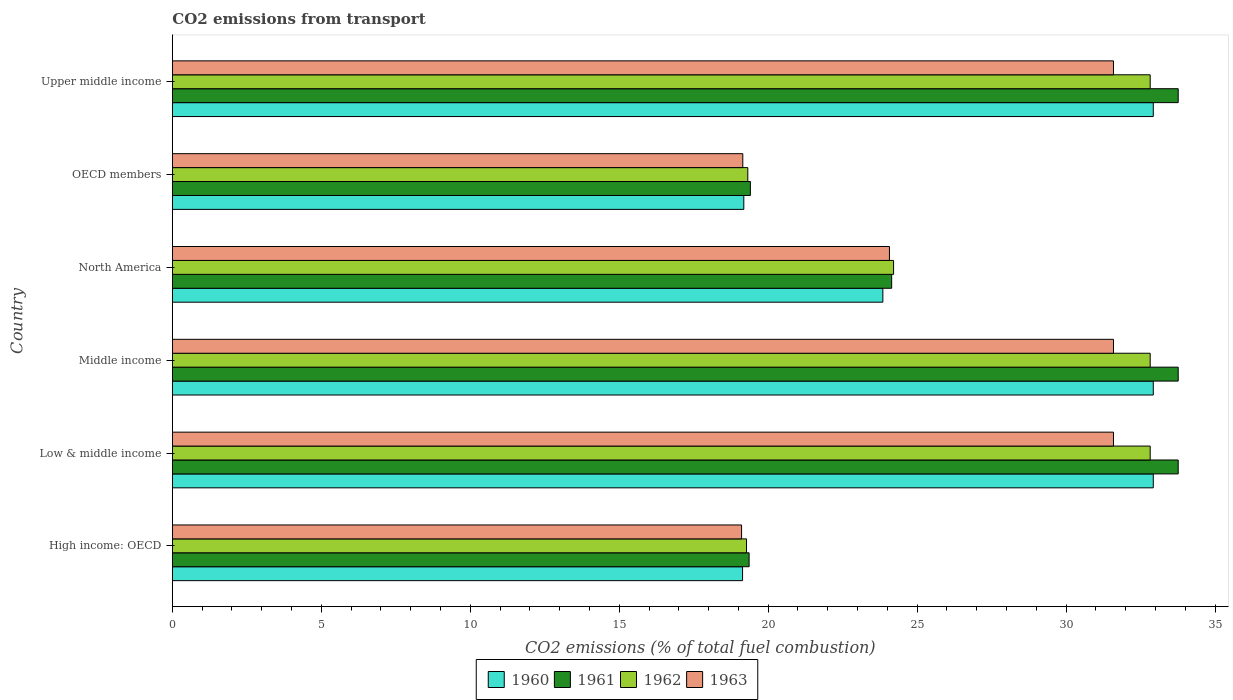How many different coloured bars are there?
Offer a terse response. 4. How many groups of bars are there?
Provide a succinct answer. 6. Are the number of bars per tick equal to the number of legend labels?
Provide a short and direct response. Yes. In how many cases, is the number of bars for a given country not equal to the number of legend labels?
Provide a succinct answer. 0. What is the total CO2 emitted in 1960 in Upper middle income?
Ensure brevity in your answer.  32.93. Across all countries, what is the maximum total CO2 emitted in 1961?
Keep it short and to the point. 33.76. Across all countries, what is the minimum total CO2 emitted in 1962?
Your answer should be compact. 19.27. In which country was the total CO2 emitted in 1963 minimum?
Offer a terse response. High income: OECD. What is the total total CO2 emitted in 1962 in the graph?
Ensure brevity in your answer.  161.27. What is the difference between the total CO2 emitted in 1963 in Middle income and that in Upper middle income?
Your answer should be very brief. 0. What is the difference between the total CO2 emitted in 1963 in North America and the total CO2 emitted in 1960 in Low & middle income?
Offer a very short reply. -8.86. What is the average total CO2 emitted in 1962 per country?
Your response must be concise. 26.88. What is the difference between the total CO2 emitted in 1961 and total CO2 emitted in 1963 in Upper middle income?
Make the answer very short. 2.17. What is the ratio of the total CO2 emitted in 1962 in North America to that in OECD members?
Provide a succinct answer. 1.25. What is the difference between the highest and the second highest total CO2 emitted in 1961?
Provide a short and direct response. 0. What is the difference between the highest and the lowest total CO2 emitted in 1960?
Offer a very short reply. 13.79. Is the sum of the total CO2 emitted in 1963 in High income: OECD and Low & middle income greater than the maximum total CO2 emitted in 1961 across all countries?
Your response must be concise. Yes. Is it the case that in every country, the sum of the total CO2 emitted in 1960 and total CO2 emitted in 1962 is greater than the sum of total CO2 emitted in 1963 and total CO2 emitted in 1961?
Your response must be concise. No. How many bars are there?
Offer a terse response. 24. Are all the bars in the graph horizontal?
Provide a short and direct response. Yes. How many countries are there in the graph?
Give a very brief answer. 6. Does the graph contain any zero values?
Give a very brief answer. No. How many legend labels are there?
Provide a succinct answer. 4. What is the title of the graph?
Give a very brief answer. CO2 emissions from transport. What is the label or title of the X-axis?
Keep it short and to the point. CO2 emissions (% of total fuel combustion). What is the label or title of the Y-axis?
Keep it short and to the point. Country. What is the CO2 emissions (% of total fuel combustion) of 1960 in High income: OECD?
Offer a very short reply. 19.14. What is the CO2 emissions (% of total fuel combustion) of 1961 in High income: OECD?
Ensure brevity in your answer.  19.36. What is the CO2 emissions (% of total fuel combustion) in 1962 in High income: OECD?
Keep it short and to the point. 19.27. What is the CO2 emissions (% of total fuel combustion) in 1963 in High income: OECD?
Offer a terse response. 19.11. What is the CO2 emissions (% of total fuel combustion) of 1960 in Low & middle income?
Your answer should be compact. 32.93. What is the CO2 emissions (% of total fuel combustion) of 1961 in Low & middle income?
Offer a very short reply. 33.76. What is the CO2 emissions (% of total fuel combustion) of 1962 in Low & middle income?
Your response must be concise. 32.82. What is the CO2 emissions (% of total fuel combustion) of 1963 in Low & middle income?
Provide a succinct answer. 31.59. What is the CO2 emissions (% of total fuel combustion) of 1960 in Middle income?
Offer a very short reply. 32.93. What is the CO2 emissions (% of total fuel combustion) of 1961 in Middle income?
Ensure brevity in your answer.  33.76. What is the CO2 emissions (% of total fuel combustion) of 1962 in Middle income?
Keep it short and to the point. 32.82. What is the CO2 emissions (% of total fuel combustion) of 1963 in Middle income?
Give a very brief answer. 31.59. What is the CO2 emissions (% of total fuel combustion) in 1960 in North America?
Provide a succinct answer. 23.85. What is the CO2 emissions (% of total fuel combustion) of 1961 in North America?
Your answer should be compact. 24.15. What is the CO2 emissions (% of total fuel combustion) of 1962 in North America?
Offer a terse response. 24.21. What is the CO2 emissions (% of total fuel combustion) of 1963 in North America?
Ensure brevity in your answer.  24.07. What is the CO2 emissions (% of total fuel combustion) of 1960 in OECD members?
Offer a very short reply. 19.18. What is the CO2 emissions (% of total fuel combustion) of 1961 in OECD members?
Make the answer very short. 19.4. What is the CO2 emissions (% of total fuel combustion) of 1962 in OECD members?
Ensure brevity in your answer.  19.32. What is the CO2 emissions (% of total fuel combustion) of 1963 in OECD members?
Offer a very short reply. 19.15. What is the CO2 emissions (% of total fuel combustion) of 1960 in Upper middle income?
Offer a terse response. 32.93. What is the CO2 emissions (% of total fuel combustion) of 1961 in Upper middle income?
Give a very brief answer. 33.76. What is the CO2 emissions (% of total fuel combustion) in 1962 in Upper middle income?
Ensure brevity in your answer.  32.82. What is the CO2 emissions (% of total fuel combustion) of 1963 in Upper middle income?
Keep it short and to the point. 31.59. Across all countries, what is the maximum CO2 emissions (% of total fuel combustion) of 1960?
Give a very brief answer. 32.93. Across all countries, what is the maximum CO2 emissions (% of total fuel combustion) in 1961?
Provide a succinct answer. 33.76. Across all countries, what is the maximum CO2 emissions (% of total fuel combustion) of 1962?
Provide a succinct answer. 32.82. Across all countries, what is the maximum CO2 emissions (% of total fuel combustion) in 1963?
Offer a very short reply. 31.59. Across all countries, what is the minimum CO2 emissions (% of total fuel combustion) of 1960?
Provide a short and direct response. 19.14. Across all countries, what is the minimum CO2 emissions (% of total fuel combustion) of 1961?
Your answer should be compact. 19.36. Across all countries, what is the minimum CO2 emissions (% of total fuel combustion) of 1962?
Your answer should be very brief. 19.27. Across all countries, what is the minimum CO2 emissions (% of total fuel combustion) in 1963?
Your answer should be very brief. 19.11. What is the total CO2 emissions (% of total fuel combustion) of 1960 in the graph?
Keep it short and to the point. 160.96. What is the total CO2 emissions (% of total fuel combustion) in 1961 in the graph?
Give a very brief answer. 164.2. What is the total CO2 emissions (% of total fuel combustion) of 1962 in the graph?
Provide a succinct answer. 161.27. What is the total CO2 emissions (% of total fuel combustion) of 1963 in the graph?
Make the answer very short. 157.1. What is the difference between the CO2 emissions (% of total fuel combustion) of 1960 in High income: OECD and that in Low & middle income?
Give a very brief answer. -13.79. What is the difference between the CO2 emissions (% of total fuel combustion) of 1961 in High income: OECD and that in Low & middle income?
Ensure brevity in your answer.  -14.4. What is the difference between the CO2 emissions (% of total fuel combustion) of 1962 in High income: OECD and that in Low & middle income?
Your answer should be very brief. -13.55. What is the difference between the CO2 emissions (% of total fuel combustion) of 1963 in High income: OECD and that in Low & middle income?
Keep it short and to the point. -12.48. What is the difference between the CO2 emissions (% of total fuel combustion) in 1960 in High income: OECD and that in Middle income?
Offer a very short reply. -13.79. What is the difference between the CO2 emissions (% of total fuel combustion) of 1961 in High income: OECD and that in Middle income?
Your answer should be very brief. -14.4. What is the difference between the CO2 emissions (% of total fuel combustion) in 1962 in High income: OECD and that in Middle income?
Your response must be concise. -13.55. What is the difference between the CO2 emissions (% of total fuel combustion) in 1963 in High income: OECD and that in Middle income?
Your answer should be compact. -12.48. What is the difference between the CO2 emissions (% of total fuel combustion) in 1960 in High income: OECD and that in North America?
Your answer should be compact. -4.71. What is the difference between the CO2 emissions (% of total fuel combustion) in 1961 in High income: OECD and that in North America?
Give a very brief answer. -4.79. What is the difference between the CO2 emissions (% of total fuel combustion) in 1962 in High income: OECD and that in North America?
Your answer should be compact. -4.94. What is the difference between the CO2 emissions (% of total fuel combustion) of 1963 in High income: OECD and that in North America?
Keep it short and to the point. -4.96. What is the difference between the CO2 emissions (% of total fuel combustion) in 1960 in High income: OECD and that in OECD members?
Provide a short and direct response. -0.04. What is the difference between the CO2 emissions (% of total fuel combustion) in 1961 in High income: OECD and that in OECD members?
Your response must be concise. -0.04. What is the difference between the CO2 emissions (% of total fuel combustion) in 1962 in High income: OECD and that in OECD members?
Your response must be concise. -0.04. What is the difference between the CO2 emissions (% of total fuel combustion) of 1963 in High income: OECD and that in OECD members?
Give a very brief answer. -0.04. What is the difference between the CO2 emissions (% of total fuel combustion) of 1960 in High income: OECD and that in Upper middle income?
Keep it short and to the point. -13.79. What is the difference between the CO2 emissions (% of total fuel combustion) in 1961 in High income: OECD and that in Upper middle income?
Provide a short and direct response. -14.4. What is the difference between the CO2 emissions (% of total fuel combustion) of 1962 in High income: OECD and that in Upper middle income?
Provide a succinct answer. -13.55. What is the difference between the CO2 emissions (% of total fuel combustion) of 1963 in High income: OECD and that in Upper middle income?
Provide a short and direct response. -12.48. What is the difference between the CO2 emissions (% of total fuel combustion) of 1962 in Low & middle income and that in Middle income?
Make the answer very short. 0. What is the difference between the CO2 emissions (% of total fuel combustion) in 1963 in Low & middle income and that in Middle income?
Keep it short and to the point. 0. What is the difference between the CO2 emissions (% of total fuel combustion) in 1960 in Low & middle income and that in North America?
Your answer should be very brief. 9.08. What is the difference between the CO2 emissions (% of total fuel combustion) of 1961 in Low & middle income and that in North America?
Your answer should be very brief. 9.62. What is the difference between the CO2 emissions (% of total fuel combustion) in 1962 in Low & middle income and that in North America?
Your response must be concise. 8.61. What is the difference between the CO2 emissions (% of total fuel combustion) in 1963 in Low & middle income and that in North America?
Provide a short and direct response. 7.52. What is the difference between the CO2 emissions (% of total fuel combustion) of 1960 in Low & middle income and that in OECD members?
Offer a very short reply. 13.75. What is the difference between the CO2 emissions (% of total fuel combustion) in 1961 in Low & middle income and that in OECD members?
Provide a short and direct response. 14.36. What is the difference between the CO2 emissions (% of total fuel combustion) of 1962 in Low & middle income and that in OECD members?
Your answer should be very brief. 13.51. What is the difference between the CO2 emissions (% of total fuel combustion) in 1963 in Low & middle income and that in OECD members?
Keep it short and to the point. 12.44. What is the difference between the CO2 emissions (% of total fuel combustion) of 1962 in Low & middle income and that in Upper middle income?
Your answer should be compact. 0. What is the difference between the CO2 emissions (% of total fuel combustion) in 1960 in Middle income and that in North America?
Provide a succinct answer. 9.08. What is the difference between the CO2 emissions (% of total fuel combustion) in 1961 in Middle income and that in North America?
Offer a terse response. 9.62. What is the difference between the CO2 emissions (% of total fuel combustion) in 1962 in Middle income and that in North America?
Offer a terse response. 8.61. What is the difference between the CO2 emissions (% of total fuel combustion) in 1963 in Middle income and that in North America?
Your answer should be compact. 7.52. What is the difference between the CO2 emissions (% of total fuel combustion) of 1960 in Middle income and that in OECD members?
Provide a short and direct response. 13.75. What is the difference between the CO2 emissions (% of total fuel combustion) in 1961 in Middle income and that in OECD members?
Your answer should be very brief. 14.36. What is the difference between the CO2 emissions (% of total fuel combustion) of 1962 in Middle income and that in OECD members?
Offer a terse response. 13.51. What is the difference between the CO2 emissions (% of total fuel combustion) in 1963 in Middle income and that in OECD members?
Your answer should be compact. 12.44. What is the difference between the CO2 emissions (% of total fuel combustion) in 1960 in Middle income and that in Upper middle income?
Your response must be concise. 0. What is the difference between the CO2 emissions (% of total fuel combustion) in 1962 in Middle income and that in Upper middle income?
Your response must be concise. 0. What is the difference between the CO2 emissions (% of total fuel combustion) in 1963 in Middle income and that in Upper middle income?
Offer a very short reply. 0. What is the difference between the CO2 emissions (% of total fuel combustion) of 1960 in North America and that in OECD members?
Your answer should be very brief. 4.67. What is the difference between the CO2 emissions (% of total fuel combustion) of 1961 in North America and that in OECD members?
Ensure brevity in your answer.  4.74. What is the difference between the CO2 emissions (% of total fuel combustion) of 1962 in North America and that in OECD members?
Keep it short and to the point. 4.89. What is the difference between the CO2 emissions (% of total fuel combustion) in 1963 in North America and that in OECD members?
Give a very brief answer. 4.92. What is the difference between the CO2 emissions (% of total fuel combustion) of 1960 in North America and that in Upper middle income?
Keep it short and to the point. -9.08. What is the difference between the CO2 emissions (% of total fuel combustion) in 1961 in North America and that in Upper middle income?
Offer a very short reply. -9.62. What is the difference between the CO2 emissions (% of total fuel combustion) of 1962 in North America and that in Upper middle income?
Offer a very short reply. -8.61. What is the difference between the CO2 emissions (% of total fuel combustion) in 1963 in North America and that in Upper middle income?
Offer a terse response. -7.52. What is the difference between the CO2 emissions (% of total fuel combustion) in 1960 in OECD members and that in Upper middle income?
Your response must be concise. -13.75. What is the difference between the CO2 emissions (% of total fuel combustion) of 1961 in OECD members and that in Upper middle income?
Give a very brief answer. -14.36. What is the difference between the CO2 emissions (% of total fuel combustion) of 1962 in OECD members and that in Upper middle income?
Offer a terse response. -13.51. What is the difference between the CO2 emissions (% of total fuel combustion) of 1963 in OECD members and that in Upper middle income?
Keep it short and to the point. -12.44. What is the difference between the CO2 emissions (% of total fuel combustion) of 1960 in High income: OECD and the CO2 emissions (% of total fuel combustion) of 1961 in Low & middle income?
Make the answer very short. -14.62. What is the difference between the CO2 emissions (% of total fuel combustion) of 1960 in High income: OECD and the CO2 emissions (% of total fuel combustion) of 1962 in Low & middle income?
Offer a very short reply. -13.68. What is the difference between the CO2 emissions (% of total fuel combustion) of 1960 in High income: OECD and the CO2 emissions (% of total fuel combustion) of 1963 in Low & middle income?
Give a very brief answer. -12.45. What is the difference between the CO2 emissions (% of total fuel combustion) in 1961 in High income: OECD and the CO2 emissions (% of total fuel combustion) in 1962 in Low & middle income?
Your response must be concise. -13.46. What is the difference between the CO2 emissions (% of total fuel combustion) of 1961 in High income: OECD and the CO2 emissions (% of total fuel combustion) of 1963 in Low & middle income?
Give a very brief answer. -12.23. What is the difference between the CO2 emissions (% of total fuel combustion) in 1962 in High income: OECD and the CO2 emissions (% of total fuel combustion) in 1963 in Low & middle income?
Offer a very short reply. -12.32. What is the difference between the CO2 emissions (% of total fuel combustion) in 1960 in High income: OECD and the CO2 emissions (% of total fuel combustion) in 1961 in Middle income?
Ensure brevity in your answer.  -14.62. What is the difference between the CO2 emissions (% of total fuel combustion) of 1960 in High income: OECD and the CO2 emissions (% of total fuel combustion) of 1962 in Middle income?
Your answer should be compact. -13.68. What is the difference between the CO2 emissions (% of total fuel combustion) in 1960 in High income: OECD and the CO2 emissions (% of total fuel combustion) in 1963 in Middle income?
Offer a terse response. -12.45. What is the difference between the CO2 emissions (% of total fuel combustion) in 1961 in High income: OECD and the CO2 emissions (% of total fuel combustion) in 1962 in Middle income?
Offer a terse response. -13.46. What is the difference between the CO2 emissions (% of total fuel combustion) of 1961 in High income: OECD and the CO2 emissions (% of total fuel combustion) of 1963 in Middle income?
Your answer should be very brief. -12.23. What is the difference between the CO2 emissions (% of total fuel combustion) of 1962 in High income: OECD and the CO2 emissions (% of total fuel combustion) of 1963 in Middle income?
Provide a short and direct response. -12.32. What is the difference between the CO2 emissions (% of total fuel combustion) of 1960 in High income: OECD and the CO2 emissions (% of total fuel combustion) of 1961 in North America?
Provide a short and direct response. -5.01. What is the difference between the CO2 emissions (% of total fuel combustion) in 1960 in High income: OECD and the CO2 emissions (% of total fuel combustion) in 1962 in North America?
Provide a succinct answer. -5.07. What is the difference between the CO2 emissions (% of total fuel combustion) of 1960 in High income: OECD and the CO2 emissions (% of total fuel combustion) of 1963 in North America?
Give a very brief answer. -4.93. What is the difference between the CO2 emissions (% of total fuel combustion) of 1961 in High income: OECD and the CO2 emissions (% of total fuel combustion) of 1962 in North America?
Offer a terse response. -4.85. What is the difference between the CO2 emissions (% of total fuel combustion) in 1961 in High income: OECD and the CO2 emissions (% of total fuel combustion) in 1963 in North America?
Make the answer very short. -4.71. What is the difference between the CO2 emissions (% of total fuel combustion) in 1962 in High income: OECD and the CO2 emissions (% of total fuel combustion) in 1963 in North America?
Offer a very short reply. -4.8. What is the difference between the CO2 emissions (% of total fuel combustion) in 1960 in High income: OECD and the CO2 emissions (% of total fuel combustion) in 1961 in OECD members?
Give a very brief answer. -0.26. What is the difference between the CO2 emissions (% of total fuel combustion) in 1960 in High income: OECD and the CO2 emissions (% of total fuel combustion) in 1962 in OECD members?
Keep it short and to the point. -0.18. What is the difference between the CO2 emissions (% of total fuel combustion) in 1960 in High income: OECD and the CO2 emissions (% of total fuel combustion) in 1963 in OECD members?
Provide a succinct answer. -0.01. What is the difference between the CO2 emissions (% of total fuel combustion) of 1961 in High income: OECD and the CO2 emissions (% of total fuel combustion) of 1962 in OECD members?
Ensure brevity in your answer.  0.04. What is the difference between the CO2 emissions (% of total fuel combustion) in 1961 in High income: OECD and the CO2 emissions (% of total fuel combustion) in 1963 in OECD members?
Your answer should be very brief. 0.21. What is the difference between the CO2 emissions (% of total fuel combustion) of 1962 in High income: OECD and the CO2 emissions (% of total fuel combustion) of 1963 in OECD members?
Your answer should be compact. 0.13. What is the difference between the CO2 emissions (% of total fuel combustion) in 1960 in High income: OECD and the CO2 emissions (% of total fuel combustion) in 1961 in Upper middle income?
Your answer should be compact. -14.62. What is the difference between the CO2 emissions (% of total fuel combustion) of 1960 in High income: OECD and the CO2 emissions (% of total fuel combustion) of 1962 in Upper middle income?
Your answer should be compact. -13.68. What is the difference between the CO2 emissions (% of total fuel combustion) in 1960 in High income: OECD and the CO2 emissions (% of total fuel combustion) in 1963 in Upper middle income?
Offer a terse response. -12.45. What is the difference between the CO2 emissions (% of total fuel combustion) in 1961 in High income: OECD and the CO2 emissions (% of total fuel combustion) in 1962 in Upper middle income?
Offer a terse response. -13.46. What is the difference between the CO2 emissions (% of total fuel combustion) of 1961 in High income: OECD and the CO2 emissions (% of total fuel combustion) of 1963 in Upper middle income?
Your response must be concise. -12.23. What is the difference between the CO2 emissions (% of total fuel combustion) of 1962 in High income: OECD and the CO2 emissions (% of total fuel combustion) of 1963 in Upper middle income?
Your answer should be very brief. -12.32. What is the difference between the CO2 emissions (% of total fuel combustion) of 1960 in Low & middle income and the CO2 emissions (% of total fuel combustion) of 1961 in Middle income?
Offer a very short reply. -0.84. What is the difference between the CO2 emissions (% of total fuel combustion) in 1960 in Low & middle income and the CO2 emissions (% of total fuel combustion) in 1962 in Middle income?
Your response must be concise. 0.1. What is the difference between the CO2 emissions (% of total fuel combustion) in 1960 in Low & middle income and the CO2 emissions (% of total fuel combustion) in 1963 in Middle income?
Your answer should be very brief. 1.34. What is the difference between the CO2 emissions (% of total fuel combustion) of 1961 in Low & middle income and the CO2 emissions (% of total fuel combustion) of 1962 in Middle income?
Provide a succinct answer. 0.94. What is the difference between the CO2 emissions (% of total fuel combustion) in 1961 in Low & middle income and the CO2 emissions (% of total fuel combustion) in 1963 in Middle income?
Offer a very short reply. 2.17. What is the difference between the CO2 emissions (% of total fuel combustion) of 1962 in Low & middle income and the CO2 emissions (% of total fuel combustion) of 1963 in Middle income?
Your answer should be very brief. 1.23. What is the difference between the CO2 emissions (% of total fuel combustion) of 1960 in Low & middle income and the CO2 emissions (% of total fuel combustion) of 1961 in North America?
Provide a short and direct response. 8.78. What is the difference between the CO2 emissions (% of total fuel combustion) in 1960 in Low & middle income and the CO2 emissions (% of total fuel combustion) in 1962 in North America?
Your response must be concise. 8.72. What is the difference between the CO2 emissions (% of total fuel combustion) in 1960 in Low & middle income and the CO2 emissions (% of total fuel combustion) in 1963 in North America?
Offer a very short reply. 8.86. What is the difference between the CO2 emissions (% of total fuel combustion) in 1961 in Low & middle income and the CO2 emissions (% of total fuel combustion) in 1962 in North America?
Offer a very short reply. 9.55. What is the difference between the CO2 emissions (% of total fuel combustion) of 1961 in Low & middle income and the CO2 emissions (% of total fuel combustion) of 1963 in North America?
Provide a succinct answer. 9.69. What is the difference between the CO2 emissions (% of total fuel combustion) of 1962 in Low & middle income and the CO2 emissions (% of total fuel combustion) of 1963 in North America?
Make the answer very short. 8.75. What is the difference between the CO2 emissions (% of total fuel combustion) in 1960 in Low & middle income and the CO2 emissions (% of total fuel combustion) in 1961 in OECD members?
Your answer should be very brief. 13.53. What is the difference between the CO2 emissions (% of total fuel combustion) in 1960 in Low & middle income and the CO2 emissions (% of total fuel combustion) in 1962 in OECD members?
Keep it short and to the point. 13.61. What is the difference between the CO2 emissions (% of total fuel combustion) of 1960 in Low & middle income and the CO2 emissions (% of total fuel combustion) of 1963 in OECD members?
Keep it short and to the point. 13.78. What is the difference between the CO2 emissions (% of total fuel combustion) in 1961 in Low & middle income and the CO2 emissions (% of total fuel combustion) in 1962 in OECD members?
Offer a very short reply. 14.45. What is the difference between the CO2 emissions (% of total fuel combustion) in 1961 in Low & middle income and the CO2 emissions (% of total fuel combustion) in 1963 in OECD members?
Your answer should be very brief. 14.62. What is the difference between the CO2 emissions (% of total fuel combustion) of 1962 in Low & middle income and the CO2 emissions (% of total fuel combustion) of 1963 in OECD members?
Offer a very short reply. 13.68. What is the difference between the CO2 emissions (% of total fuel combustion) in 1960 in Low & middle income and the CO2 emissions (% of total fuel combustion) in 1961 in Upper middle income?
Your answer should be very brief. -0.84. What is the difference between the CO2 emissions (% of total fuel combustion) of 1960 in Low & middle income and the CO2 emissions (% of total fuel combustion) of 1962 in Upper middle income?
Ensure brevity in your answer.  0.1. What is the difference between the CO2 emissions (% of total fuel combustion) in 1960 in Low & middle income and the CO2 emissions (% of total fuel combustion) in 1963 in Upper middle income?
Provide a succinct answer. 1.34. What is the difference between the CO2 emissions (% of total fuel combustion) of 1961 in Low & middle income and the CO2 emissions (% of total fuel combustion) of 1962 in Upper middle income?
Make the answer very short. 0.94. What is the difference between the CO2 emissions (% of total fuel combustion) of 1961 in Low & middle income and the CO2 emissions (% of total fuel combustion) of 1963 in Upper middle income?
Provide a succinct answer. 2.17. What is the difference between the CO2 emissions (% of total fuel combustion) of 1962 in Low & middle income and the CO2 emissions (% of total fuel combustion) of 1963 in Upper middle income?
Give a very brief answer. 1.23. What is the difference between the CO2 emissions (% of total fuel combustion) in 1960 in Middle income and the CO2 emissions (% of total fuel combustion) in 1961 in North America?
Make the answer very short. 8.78. What is the difference between the CO2 emissions (% of total fuel combustion) in 1960 in Middle income and the CO2 emissions (% of total fuel combustion) in 1962 in North America?
Provide a short and direct response. 8.72. What is the difference between the CO2 emissions (% of total fuel combustion) in 1960 in Middle income and the CO2 emissions (% of total fuel combustion) in 1963 in North America?
Ensure brevity in your answer.  8.86. What is the difference between the CO2 emissions (% of total fuel combustion) in 1961 in Middle income and the CO2 emissions (% of total fuel combustion) in 1962 in North America?
Give a very brief answer. 9.55. What is the difference between the CO2 emissions (% of total fuel combustion) of 1961 in Middle income and the CO2 emissions (% of total fuel combustion) of 1963 in North America?
Ensure brevity in your answer.  9.69. What is the difference between the CO2 emissions (% of total fuel combustion) of 1962 in Middle income and the CO2 emissions (% of total fuel combustion) of 1963 in North America?
Provide a succinct answer. 8.75. What is the difference between the CO2 emissions (% of total fuel combustion) of 1960 in Middle income and the CO2 emissions (% of total fuel combustion) of 1961 in OECD members?
Give a very brief answer. 13.53. What is the difference between the CO2 emissions (% of total fuel combustion) of 1960 in Middle income and the CO2 emissions (% of total fuel combustion) of 1962 in OECD members?
Your answer should be very brief. 13.61. What is the difference between the CO2 emissions (% of total fuel combustion) of 1960 in Middle income and the CO2 emissions (% of total fuel combustion) of 1963 in OECD members?
Your answer should be compact. 13.78. What is the difference between the CO2 emissions (% of total fuel combustion) in 1961 in Middle income and the CO2 emissions (% of total fuel combustion) in 1962 in OECD members?
Offer a very short reply. 14.45. What is the difference between the CO2 emissions (% of total fuel combustion) of 1961 in Middle income and the CO2 emissions (% of total fuel combustion) of 1963 in OECD members?
Offer a terse response. 14.62. What is the difference between the CO2 emissions (% of total fuel combustion) of 1962 in Middle income and the CO2 emissions (% of total fuel combustion) of 1963 in OECD members?
Your answer should be compact. 13.68. What is the difference between the CO2 emissions (% of total fuel combustion) in 1960 in Middle income and the CO2 emissions (% of total fuel combustion) in 1961 in Upper middle income?
Offer a terse response. -0.84. What is the difference between the CO2 emissions (% of total fuel combustion) of 1960 in Middle income and the CO2 emissions (% of total fuel combustion) of 1962 in Upper middle income?
Offer a very short reply. 0.1. What is the difference between the CO2 emissions (% of total fuel combustion) of 1960 in Middle income and the CO2 emissions (% of total fuel combustion) of 1963 in Upper middle income?
Make the answer very short. 1.34. What is the difference between the CO2 emissions (% of total fuel combustion) of 1961 in Middle income and the CO2 emissions (% of total fuel combustion) of 1962 in Upper middle income?
Offer a very short reply. 0.94. What is the difference between the CO2 emissions (% of total fuel combustion) in 1961 in Middle income and the CO2 emissions (% of total fuel combustion) in 1963 in Upper middle income?
Keep it short and to the point. 2.17. What is the difference between the CO2 emissions (% of total fuel combustion) of 1962 in Middle income and the CO2 emissions (% of total fuel combustion) of 1963 in Upper middle income?
Provide a succinct answer. 1.23. What is the difference between the CO2 emissions (% of total fuel combustion) in 1960 in North America and the CO2 emissions (% of total fuel combustion) in 1961 in OECD members?
Your answer should be compact. 4.45. What is the difference between the CO2 emissions (% of total fuel combustion) of 1960 in North America and the CO2 emissions (% of total fuel combustion) of 1962 in OECD members?
Give a very brief answer. 4.53. What is the difference between the CO2 emissions (% of total fuel combustion) of 1960 in North America and the CO2 emissions (% of total fuel combustion) of 1963 in OECD members?
Provide a short and direct response. 4.7. What is the difference between the CO2 emissions (% of total fuel combustion) of 1961 in North America and the CO2 emissions (% of total fuel combustion) of 1962 in OECD members?
Provide a succinct answer. 4.83. What is the difference between the CO2 emissions (% of total fuel combustion) in 1961 in North America and the CO2 emissions (% of total fuel combustion) in 1963 in OECD members?
Your answer should be very brief. 5. What is the difference between the CO2 emissions (% of total fuel combustion) in 1962 in North America and the CO2 emissions (% of total fuel combustion) in 1963 in OECD members?
Your response must be concise. 5.06. What is the difference between the CO2 emissions (% of total fuel combustion) of 1960 in North America and the CO2 emissions (% of total fuel combustion) of 1961 in Upper middle income?
Offer a very short reply. -9.91. What is the difference between the CO2 emissions (% of total fuel combustion) in 1960 in North America and the CO2 emissions (% of total fuel combustion) in 1962 in Upper middle income?
Your response must be concise. -8.97. What is the difference between the CO2 emissions (% of total fuel combustion) of 1960 in North America and the CO2 emissions (% of total fuel combustion) of 1963 in Upper middle income?
Your answer should be very brief. -7.74. What is the difference between the CO2 emissions (% of total fuel combustion) in 1961 in North America and the CO2 emissions (% of total fuel combustion) in 1962 in Upper middle income?
Your response must be concise. -8.68. What is the difference between the CO2 emissions (% of total fuel combustion) in 1961 in North America and the CO2 emissions (% of total fuel combustion) in 1963 in Upper middle income?
Provide a short and direct response. -7.45. What is the difference between the CO2 emissions (% of total fuel combustion) in 1962 in North America and the CO2 emissions (% of total fuel combustion) in 1963 in Upper middle income?
Your answer should be compact. -7.38. What is the difference between the CO2 emissions (% of total fuel combustion) in 1960 in OECD members and the CO2 emissions (% of total fuel combustion) in 1961 in Upper middle income?
Your answer should be very brief. -14.58. What is the difference between the CO2 emissions (% of total fuel combustion) of 1960 in OECD members and the CO2 emissions (% of total fuel combustion) of 1962 in Upper middle income?
Provide a succinct answer. -13.64. What is the difference between the CO2 emissions (% of total fuel combustion) of 1960 in OECD members and the CO2 emissions (% of total fuel combustion) of 1963 in Upper middle income?
Your answer should be compact. -12.41. What is the difference between the CO2 emissions (% of total fuel combustion) in 1961 in OECD members and the CO2 emissions (% of total fuel combustion) in 1962 in Upper middle income?
Your answer should be compact. -13.42. What is the difference between the CO2 emissions (% of total fuel combustion) of 1961 in OECD members and the CO2 emissions (% of total fuel combustion) of 1963 in Upper middle income?
Make the answer very short. -12.19. What is the difference between the CO2 emissions (% of total fuel combustion) in 1962 in OECD members and the CO2 emissions (% of total fuel combustion) in 1963 in Upper middle income?
Your answer should be compact. -12.28. What is the average CO2 emissions (% of total fuel combustion) of 1960 per country?
Keep it short and to the point. 26.83. What is the average CO2 emissions (% of total fuel combustion) of 1961 per country?
Make the answer very short. 27.37. What is the average CO2 emissions (% of total fuel combustion) in 1962 per country?
Offer a terse response. 26.88. What is the average CO2 emissions (% of total fuel combustion) in 1963 per country?
Make the answer very short. 26.18. What is the difference between the CO2 emissions (% of total fuel combustion) in 1960 and CO2 emissions (% of total fuel combustion) in 1961 in High income: OECD?
Ensure brevity in your answer.  -0.22. What is the difference between the CO2 emissions (% of total fuel combustion) of 1960 and CO2 emissions (% of total fuel combustion) of 1962 in High income: OECD?
Give a very brief answer. -0.13. What is the difference between the CO2 emissions (% of total fuel combustion) of 1960 and CO2 emissions (% of total fuel combustion) of 1963 in High income: OECD?
Your response must be concise. 0.03. What is the difference between the CO2 emissions (% of total fuel combustion) of 1961 and CO2 emissions (% of total fuel combustion) of 1962 in High income: OECD?
Ensure brevity in your answer.  0.09. What is the difference between the CO2 emissions (% of total fuel combustion) of 1961 and CO2 emissions (% of total fuel combustion) of 1963 in High income: OECD?
Provide a short and direct response. 0.25. What is the difference between the CO2 emissions (% of total fuel combustion) in 1962 and CO2 emissions (% of total fuel combustion) in 1963 in High income: OECD?
Provide a short and direct response. 0.17. What is the difference between the CO2 emissions (% of total fuel combustion) in 1960 and CO2 emissions (% of total fuel combustion) in 1961 in Low & middle income?
Provide a succinct answer. -0.84. What is the difference between the CO2 emissions (% of total fuel combustion) of 1960 and CO2 emissions (% of total fuel combustion) of 1962 in Low & middle income?
Make the answer very short. 0.1. What is the difference between the CO2 emissions (% of total fuel combustion) in 1960 and CO2 emissions (% of total fuel combustion) in 1963 in Low & middle income?
Provide a succinct answer. 1.34. What is the difference between the CO2 emissions (% of total fuel combustion) in 1961 and CO2 emissions (% of total fuel combustion) in 1962 in Low & middle income?
Provide a short and direct response. 0.94. What is the difference between the CO2 emissions (% of total fuel combustion) of 1961 and CO2 emissions (% of total fuel combustion) of 1963 in Low & middle income?
Keep it short and to the point. 2.17. What is the difference between the CO2 emissions (% of total fuel combustion) of 1962 and CO2 emissions (% of total fuel combustion) of 1963 in Low & middle income?
Provide a succinct answer. 1.23. What is the difference between the CO2 emissions (% of total fuel combustion) in 1960 and CO2 emissions (% of total fuel combustion) in 1961 in Middle income?
Provide a short and direct response. -0.84. What is the difference between the CO2 emissions (% of total fuel combustion) of 1960 and CO2 emissions (% of total fuel combustion) of 1962 in Middle income?
Your response must be concise. 0.1. What is the difference between the CO2 emissions (% of total fuel combustion) in 1960 and CO2 emissions (% of total fuel combustion) in 1963 in Middle income?
Give a very brief answer. 1.34. What is the difference between the CO2 emissions (% of total fuel combustion) in 1961 and CO2 emissions (% of total fuel combustion) in 1962 in Middle income?
Make the answer very short. 0.94. What is the difference between the CO2 emissions (% of total fuel combustion) of 1961 and CO2 emissions (% of total fuel combustion) of 1963 in Middle income?
Offer a very short reply. 2.17. What is the difference between the CO2 emissions (% of total fuel combustion) in 1962 and CO2 emissions (% of total fuel combustion) in 1963 in Middle income?
Your answer should be very brief. 1.23. What is the difference between the CO2 emissions (% of total fuel combustion) in 1960 and CO2 emissions (% of total fuel combustion) in 1961 in North America?
Your response must be concise. -0.3. What is the difference between the CO2 emissions (% of total fuel combustion) of 1960 and CO2 emissions (% of total fuel combustion) of 1962 in North America?
Offer a terse response. -0.36. What is the difference between the CO2 emissions (% of total fuel combustion) of 1960 and CO2 emissions (% of total fuel combustion) of 1963 in North America?
Offer a terse response. -0.22. What is the difference between the CO2 emissions (% of total fuel combustion) of 1961 and CO2 emissions (% of total fuel combustion) of 1962 in North America?
Offer a very short reply. -0.06. What is the difference between the CO2 emissions (% of total fuel combustion) of 1961 and CO2 emissions (% of total fuel combustion) of 1963 in North America?
Make the answer very short. 0.07. What is the difference between the CO2 emissions (% of total fuel combustion) of 1962 and CO2 emissions (% of total fuel combustion) of 1963 in North America?
Ensure brevity in your answer.  0.14. What is the difference between the CO2 emissions (% of total fuel combustion) in 1960 and CO2 emissions (% of total fuel combustion) in 1961 in OECD members?
Offer a terse response. -0.22. What is the difference between the CO2 emissions (% of total fuel combustion) of 1960 and CO2 emissions (% of total fuel combustion) of 1962 in OECD members?
Your response must be concise. -0.13. What is the difference between the CO2 emissions (% of total fuel combustion) in 1960 and CO2 emissions (% of total fuel combustion) in 1963 in OECD members?
Offer a terse response. 0.03. What is the difference between the CO2 emissions (% of total fuel combustion) in 1961 and CO2 emissions (% of total fuel combustion) in 1962 in OECD members?
Provide a short and direct response. 0.09. What is the difference between the CO2 emissions (% of total fuel combustion) in 1961 and CO2 emissions (% of total fuel combustion) in 1963 in OECD members?
Provide a short and direct response. 0.25. What is the difference between the CO2 emissions (% of total fuel combustion) in 1962 and CO2 emissions (% of total fuel combustion) in 1963 in OECD members?
Offer a terse response. 0.17. What is the difference between the CO2 emissions (% of total fuel combustion) of 1960 and CO2 emissions (% of total fuel combustion) of 1961 in Upper middle income?
Offer a very short reply. -0.84. What is the difference between the CO2 emissions (% of total fuel combustion) in 1960 and CO2 emissions (% of total fuel combustion) in 1962 in Upper middle income?
Offer a terse response. 0.1. What is the difference between the CO2 emissions (% of total fuel combustion) in 1960 and CO2 emissions (% of total fuel combustion) in 1963 in Upper middle income?
Offer a terse response. 1.34. What is the difference between the CO2 emissions (% of total fuel combustion) of 1961 and CO2 emissions (% of total fuel combustion) of 1962 in Upper middle income?
Offer a terse response. 0.94. What is the difference between the CO2 emissions (% of total fuel combustion) in 1961 and CO2 emissions (% of total fuel combustion) in 1963 in Upper middle income?
Give a very brief answer. 2.17. What is the difference between the CO2 emissions (% of total fuel combustion) in 1962 and CO2 emissions (% of total fuel combustion) in 1963 in Upper middle income?
Offer a very short reply. 1.23. What is the ratio of the CO2 emissions (% of total fuel combustion) in 1960 in High income: OECD to that in Low & middle income?
Your answer should be compact. 0.58. What is the ratio of the CO2 emissions (% of total fuel combustion) of 1961 in High income: OECD to that in Low & middle income?
Your answer should be compact. 0.57. What is the ratio of the CO2 emissions (% of total fuel combustion) in 1962 in High income: OECD to that in Low & middle income?
Ensure brevity in your answer.  0.59. What is the ratio of the CO2 emissions (% of total fuel combustion) of 1963 in High income: OECD to that in Low & middle income?
Give a very brief answer. 0.6. What is the ratio of the CO2 emissions (% of total fuel combustion) of 1960 in High income: OECD to that in Middle income?
Ensure brevity in your answer.  0.58. What is the ratio of the CO2 emissions (% of total fuel combustion) in 1961 in High income: OECD to that in Middle income?
Offer a terse response. 0.57. What is the ratio of the CO2 emissions (% of total fuel combustion) of 1962 in High income: OECD to that in Middle income?
Your response must be concise. 0.59. What is the ratio of the CO2 emissions (% of total fuel combustion) in 1963 in High income: OECD to that in Middle income?
Your answer should be compact. 0.6. What is the ratio of the CO2 emissions (% of total fuel combustion) in 1960 in High income: OECD to that in North America?
Keep it short and to the point. 0.8. What is the ratio of the CO2 emissions (% of total fuel combustion) of 1961 in High income: OECD to that in North America?
Offer a very short reply. 0.8. What is the ratio of the CO2 emissions (% of total fuel combustion) of 1962 in High income: OECD to that in North America?
Offer a very short reply. 0.8. What is the ratio of the CO2 emissions (% of total fuel combustion) of 1963 in High income: OECD to that in North America?
Ensure brevity in your answer.  0.79. What is the ratio of the CO2 emissions (% of total fuel combustion) of 1961 in High income: OECD to that in OECD members?
Provide a short and direct response. 1. What is the ratio of the CO2 emissions (% of total fuel combustion) in 1960 in High income: OECD to that in Upper middle income?
Your answer should be very brief. 0.58. What is the ratio of the CO2 emissions (% of total fuel combustion) of 1961 in High income: OECD to that in Upper middle income?
Provide a short and direct response. 0.57. What is the ratio of the CO2 emissions (% of total fuel combustion) in 1962 in High income: OECD to that in Upper middle income?
Keep it short and to the point. 0.59. What is the ratio of the CO2 emissions (% of total fuel combustion) of 1963 in High income: OECD to that in Upper middle income?
Your answer should be very brief. 0.6. What is the ratio of the CO2 emissions (% of total fuel combustion) in 1962 in Low & middle income to that in Middle income?
Keep it short and to the point. 1. What is the ratio of the CO2 emissions (% of total fuel combustion) in 1960 in Low & middle income to that in North America?
Make the answer very short. 1.38. What is the ratio of the CO2 emissions (% of total fuel combustion) in 1961 in Low & middle income to that in North America?
Provide a succinct answer. 1.4. What is the ratio of the CO2 emissions (% of total fuel combustion) of 1962 in Low & middle income to that in North America?
Keep it short and to the point. 1.36. What is the ratio of the CO2 emissions (% of total fuel combustion) of 1963 in Low & middle income to that in North America?
Give a very brief answer. 1.31. What is the ratio of the CO2 emissions (% of total fuel combustion) in 1960 in Low & middle income to that in OECD members?
Your answer should be compact. 1.72. What is the ratio of the CO2 emissions (% of total fuel combustion) in 1961 in Low & middle income to that in OECD members?
Give a very brief answer. 1.74. What is the ratio of the CO2 emissions (% of total fuel combustion) in 1962 in Low & middle income to that in OECD members?
Offer a very short reply. 1.7. What is the ratio of the CO2 emissions (% of total fuel combustion) in 1963 in Low & middle income to that in OECD members?
Give a very brief answer. 1.65. What is the ratio of the CO2 emissions (% of total fuel combustion) in 1961 in Low & middle income to that in Upper middle income?
Provide a short and direct response. 1. What is the ratio of the CO2 emissions (% of total fuel combustion) of 1963 in Low & middle income to that in Upper middle income?
Keep it short and to the point. 1. What is the ratio of the CO2 emissions (% of total fuel combustion) in 1960 in Middle income to that in North America?
Make the answer very short. 1.38. What is the ratio of the CO2 emissions (% of total fuel combustion) in 1961 in Middle income to that in North America?
Make the answer very short. 1.4. What is the ratio of the CO2 emissions (% of total fuel combustion) in 1962 in Middle income to that in North America?
Your answer should be compact. 1.36. What is the ratio of the CO2 emissions (% of total fuel combustion) of 1963 in Middle income to that in North America?
Your answer should be very brief. 1.31. What is the ratio of the CO2 emissions (% of total fuel combustion) in 1960 in Middle income to that in OECD members?
Make the answer very short. 1.72. What is the ratio of the CO2 emissions (% of total fuel combustion) in 1961 in Middle income to that in OECD members?
Your answer should be very brief. 1.74. What is the ratio of the CO2 emissions (% of total fuel combustion) of 1962 in Middle income to that in OECD members?
Keep it short and to the point. 1.7. What is the ratio of the CO2 emissions (% of total fuel combustion) in 1963 in Middle income to that in OECD members?
Give a very brief answer. 1.65. What is the ratio of the CO2 emissions (% of total fuel combustion) in 1961 in Middle income to that in Upper middle income?
Ensure brevity in your answer.  1. What is the ratio of the CO2 emissions (% of total fuel combustion) of 1960 in North America to that in OECD members?
Provide a short and direct response. 1.24. What is the ratio of the CO2 emissions (% of total fuel combustion) in 1961 in North America to that in OECD members?
Make the answer very short. 1.24. What is the ratio of the CO2 emissions (% of total fuel combustion) in 1962 in North America to that in OECD members?
Offer a terse response. 1.25. What is the ratio of the CO2 emissions (% of total fuel combustion) of 1963 in North America to that in OECD members?
Offer a terse response. 1.26. What is the ratio of the CO2 emissions (% of total fuel combustion) of 1960 in North America to that in Upper middle income?
Give a very brief answer. 0.72. What is the ratio of the CO2 emissions (% of total fuel combustion) in 1961 in North America to that in Upper middle income?
Offer a terse response. 0.72. What is the ratio of the CO2 emissions (% of total fuel combustion) in 1962 in North America to that in Upper middle income?
Offer a terse response. 0.74. What is the ratio of the CO2 emissions (% of total fuel combustion) in 1963 in North America to that in Upper middle income?
Provide a short and direct response. 0.76. What is the ratio of the CO2 emissions (% of total fuel combustion) in 1960 in OECD members to that in Upper middle income?
Make the answer very short. 0.58. What is the ratio of the CO2 emissions (% of total fuel combustion) in 1961 in OECD members to that in Upper middle income?
Your answer should be compact. 0.57. What is the ratio of the CO2 emissions (% of total fuel combustion) of 1962 in OECD members to that in Upper middle income?
Make the answer very short. 0.59. What is the ratio of the CO2 emissions (% of total fuel combustion) in 1963 in OECD members to that in Upper middle income?
Your response must be concise. 0.61. What is the difference between the highest and the second highest CO2 emissions (% of total fuel combustion) in 1961?
Provide a short and direct response. 0. What is the difference between the highest and the second highest CO2 emissions (% of total fuel combustion) of 1963?
Provide a succinct answer. 0. What is the difference between the highest and the lowest CO2 emissions (% of total fuel combustion) of 1960?
Keep it short and to the point. 13.79. What is the difference between the highest and the lowest CO2 emissions (% of total fuel combustion) in 1961?
Provide a succinct answer. 14.4. What is the difference between the highest and the lowest CO2 emissions (% of total fuel combustion) of 1962?
Provide a succinct answer. 13.55. What is the difference between the highest and the lowest CO2 emissions (% of total fuel combustion) of 1963?
Your answer should be very brief. 12.48. 